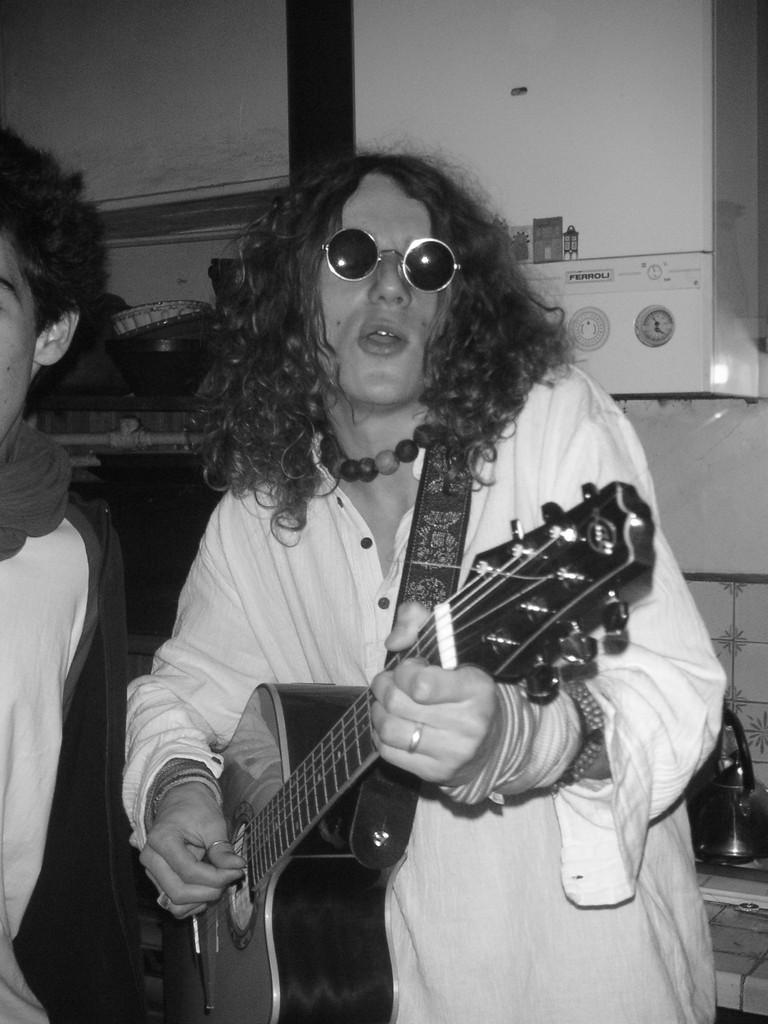What is the main subject of the image? There is a person in the image. What is the person wearing? The person is wearing a white dress. What is the person doing in the image? The person is playing a guitar. How many vegetables can be seen in the image? There are no vegetables present in the image. What type of slave is depicted in the image? There is no depiction of a slave in the image; it features a person playing a guitar. 